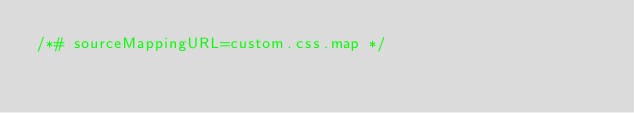Convert code to text. <code><loc_0><loc_0><loc_500><loc_500><_CSS_>/*# sourceMappingURL=custom.css.map */</code> 